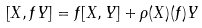Convert formula to latex. <formula><loc_0><loc_0><loc_500><loc_500>\left [ X , f Y \right ] = f [ X , Y ] + \rho ( X ) ( f ) Y</formula> 